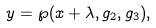Convert formula to latex. <formula><loc_0><loc_0><loc_500><loc_500>y = \wp ( x + \lambda , g _ { 2 } , g _ { 3 } ) ,</formula> 